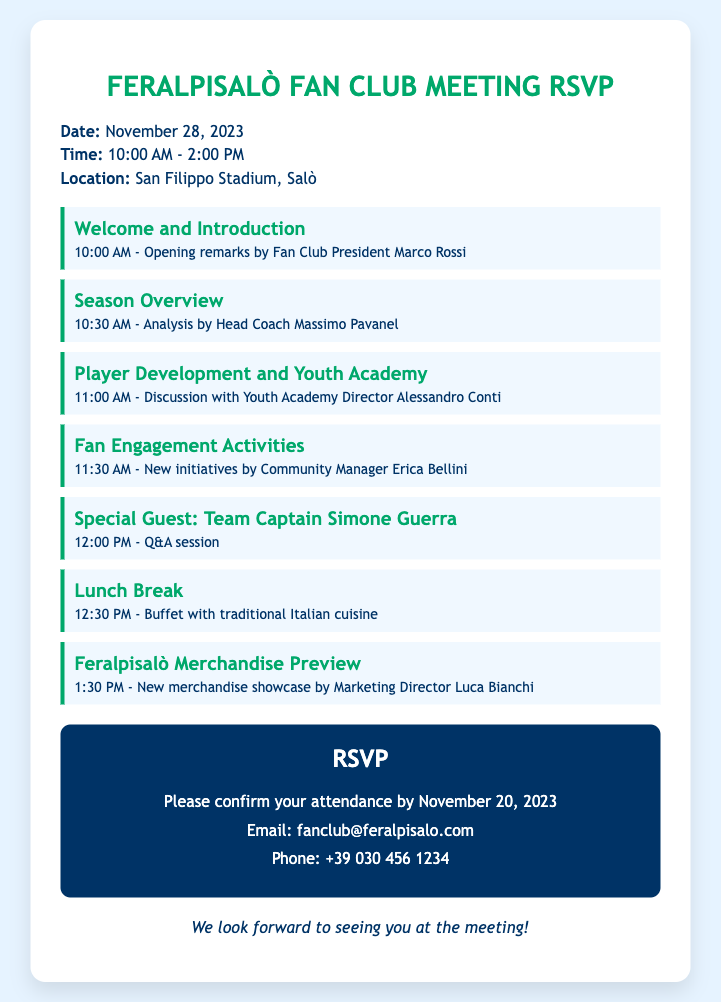What is the date of the meeting? The date of the meeting is clearly stated in the document.
Answer: November 28, 2023 Who opens the meeting? The opener of the meeting is mentioned in the introduction section.
Answer: Marco Rossi What time does the lunch break start? The starting time for the lunch break is listed in the meeting agenda.
Answer: 12:30 PM Who is the special guest at the meeting? The document specifies the special guest for a Q&A session in the agenda.
Answer: Simone Guerra What is included in the lunch break? The lunch break section mentions the type of food served.
Answer: Traditional Italian cuisine How long is the meeting scheduled to last? The full duration of the meeting can be calculated from the start and end times mentioned.
Answer: 4 hours What will be analyzed by the Head Coach? The specific topic to be analyzed by the Head Coach is indicated in the agenda.
Answer: Season Overview How can attendees confirm their attendance? The RSVP section outlines how attendees can confirm their attendance.
Answer: Email or phone What is the last topic discussed before the buffet? The agenda lists the topics in chronological order, mentioning the last one before lunch.
Answer: Feralpisalò Merchandise Preview 